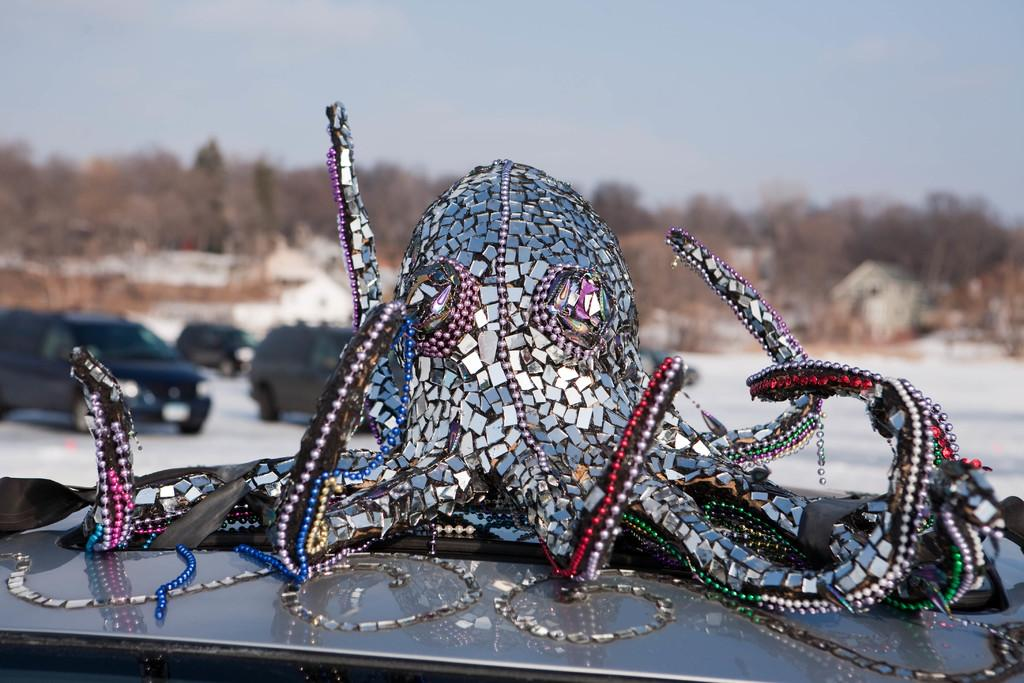What is the main subject of the image? The main subject of the image is a sculpture on a vehicle. What else can be seen on the ground in the image? There are other vehicles on the ground in the image. What can be seen in the background of the image? Trees and the sky are visible in the background of the image. What type of animal is making a wish in the image? There is no animal present in the image, and therefore no such activity can be observed. 